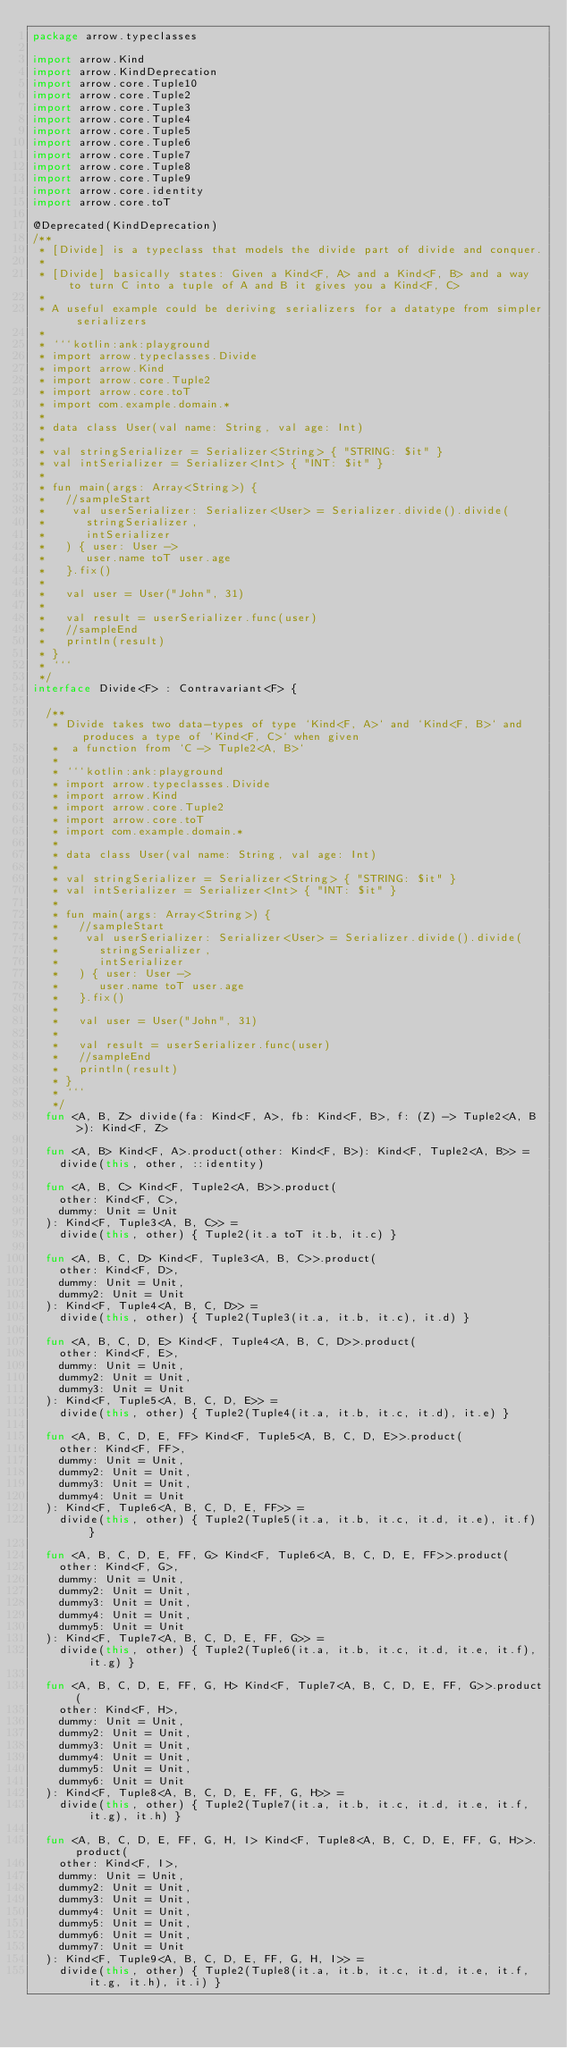<code> <loc_0><loc_0><loc_500><loc_500><_Kotlin_>package arrow.typeclasses

import arrow.Kind
import arrow.KindDeprecation
import arrow.core.Tuple10
import arrow.core.Tuple2
import arrow.core.Tuple3
import arrow.core.Tuple4
import arrow.core.Tuple5
import arrow.core.Tuple6
import arrow.core.Tuple7
import arrow.core.Tuple8
import arrow.core.Tuple9
import arrow.core.identity
import arrow.core.toT

@Deprecated(KindDeprecation)
/**
 * [Divide] is a typeclass that models the divide part of divide and conquer.
 *
 * [Divide] basically states: Given a Kind<F, A> and a Kind<F, B> and a way to turn C into a tuple of A and B it gives you a Kind<F, C>
 *
 * A useful example could be deriving serializers for a datatype from simpler serializers
 *
 * ```kotlin:ank:playground
 * import arrow.typeclasses.Divide
 * import arrow.Kind
 * import arrow.core.Tuple2
 * import arrow.core.toT
 * import com.example.domain.*
 *
 * data class User(val name: String, val age: Int)
 *
 * val stringSerializer = Serializer<String> { "STRING: $it" }
 * val intSerializer = Serializer<Int> { "INT: $it" }
 *
 * fun main(args: Array<String>) {
 *   //sampleStart
 *    val userSerializer: Serializer<User> = Serializer.divide().divide(
 *      stringSerializer,
 *      intSerializer
 *   ) { user: User ->
 *      user.name toT user.age
 *   }.fix()
 *
 *   val user = User("John", 31)
 *
 *   val result = userSerializer.func(user)
 *   //sampleEnd
 *   println(result)
 * }
 * ```
 */
interface Divide<F> : Contravariant<F> {

  /**
   * Divide takes two data-types of type `Kind<F, A>` and `Kind<F, B>` and produces a type of `Kind<F, C>` when given
   *  a function from `C -> Tuple2<A, B>`
   *
   * ```kotlin:ank:playground
   * import arrow.typeclasses.Divide
   * import arrow.Kind
   * import arrow.core.Tuple2
   * import arrow.core.toT
   * import com.example.domain.*
   *
   * data class User(val name: String, val age: Int)
   *
   * val stringSerializer = Serializer<String> { "STRING: $it" }
   * val intSerializer = Serializer<Int> { "INT: $it" }
   *
   * fun main(args: Array<String>) {
   *   //sampleStart
   *    val userSerializer: Serializer<User> = Serializer.divide().divide(
   *      stringSerializer,
   *      intSerializer
   *   ) { user: User ->
   *      user.name toT user.age
   *   }.fix()
   *
   *   val user = User("John", 31)
   *
   *   val result = userSerializer.func(user)
   *   //sampleEnd
   *   println(result)
   * }
   * ```
   */
  fun <A, B, Z> divide(fa: Kind<F, A>, fb: Kind<F, B>, f: (Z) -> Tuple2<A, B>): Kind<F, Z>

  fun <A, B> Kind<F, A>.product(other: Kind<F, B>): Kind<F, Tuple2<A, B>> =
    divide(this, other, ::identity)

  fun <A, B, C> Kind<F, Tuple2<A, B>>.product(
    other: Kind<F, C>,
    dummy: Unit = Unit
  ): Kind<F, Tuple3<A, B, C>> =
    divide(this, other) { Tuple2(it.a toT it.b, it.c) }

  fun <A, B, C, D> Kind<F, Tuple3<A, B, C>>.product(
    other: Kind<F, D>,
    dummy: Unit = Unit,
    dummy2: Unit = Unit
  ): Kind<F, Tuple4<A, B, C, D>> =
    divide(this, other) { Tuple2(Tuple3(it.a, it.b, it.c), it.d) }

  fun <A, B, C, D, E> Kind<F, Tuple4<A, B, C, D>>.product(
    other: Kind<F, E>,
    dummy: Unit = Unit,
    dummy2: Unit = Unit,
    dummy3: Unit = Unit
  ): Kind<F, Tuple5<A, B, C, D, E>> =
    divide(this, other) { Tuple2(Tuple4(it.a, it.b, it.c, it.d), it.e) }

  fun <A, B, C, D, E, FF> Kind<F, Tuple5<A, B, C, D, E>>.product(
    other: Kind<F, FF>,
    dummy: Unit = Unit,
    dummy2: Unit = Unit,
    dummy3: Unit = Unit,
    dummy4: Unit = Unit
  ): Kind<F, Tuple6<A, B, C, D, E, FF>> =
    divide(this, other) { Tuple2(Tuple5(it.a, it.b, it.c, it.d, it.e), it.f) }

  fun <A, B, C, D, E, FF, G> Kind<F, Tuple6<A, B, C, D, E, FF>>.product(
    other: Kind<F, G>,
    dummy: Unit = Unit,
    dummy2: Unit = Unit,
    dummy3: Unit = Unit,
    dummy4: Unit = Unit,
    dummy5: Unit = Unit
  ): Kind<F, Tuple7<A, B, C, D, E, FF, G>> =
    divide(this, other) { Tuple2(Tuple6(it.a, it.b, it.c, it.d, it.e, it.f), it.g) }

  fun <A, B, C, D, E, FF, G, H> Kind<F, Tuple7<A, B, C, D, E, FF, G>>.product(
    other: Kind<F, H>,
    dummy: Unit = Unit,
    dummy2: Unit = Unit,
    dummy3: Unit = Unit,
    dummy4: Unit = Unit,
    dummy5: Unit = Unit,
    dummy6: Unit = Unit
  ): Kind<F, Tuple8<A, B, C, D, E, FF, G, H>> =
    divide(this, other) { Tuple2(Tuple7(it.a, it.b, it.c, it.d, it.e, it.f, it.g), it.h) }

  fun <A, B, C, D, E, FF, G, H, I> Kind<F, Tuple8<A, B, C, D, E, FF, G, H>>.product(
    other: Kind<F, I>,
    dummy: Unit = Unit,
    dummy2: Unit = Unit,
    dummy3: Unit = Unit,
    dummy4: Unit = Unit,
    dummy5: Unit = Unit,
    dummy6: Unit = Unit,
    dummy7: Unit = Unit
  ): Kind<F, Tuple9<A, B, C, D, E, FF, G, H, I>> =
    divide(this, other) { Tuple2(Tuple8(it.a, it.b, it.c, it.d, it.e, it.f, it.g, it.h), it.i) }
</code> 